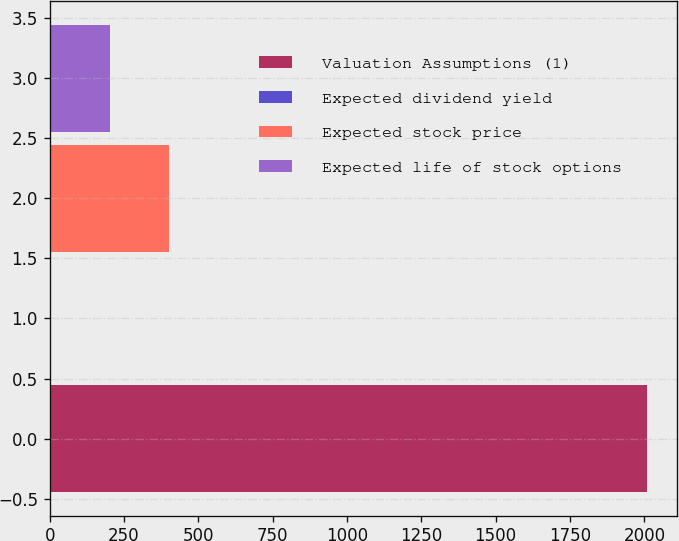Convert chart. <chart><loc_0><loc_0><loc_500><loc_500><bar_chart><fcel>Valuation Assumptions (1)<fcel>Expected dividend yield<fcel>Expected stock price<fcel>Expected life of stock options<nl><fcel>2009<fcel>1.6<fcel>403.08<fcel>202.34<nl></chart> 